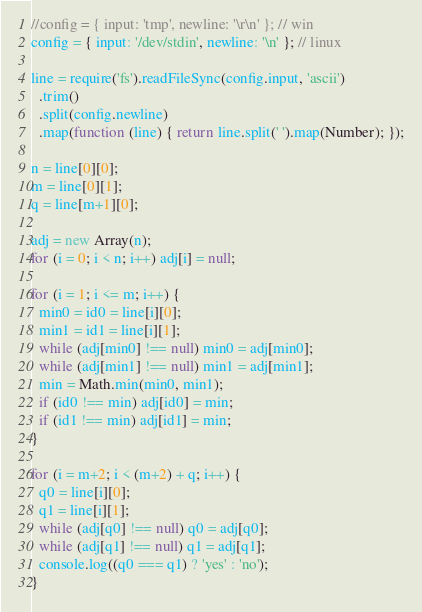<code> <loc_0><loc_0><loc_500><loc_500><_JavaScript_>//config = { input: 'tmp', newline: '\r\n' }; // win
config = { input: '/dev/stdin', newline: '\n' }; // linux

line = require('fs').readFileSync(config.input, 'ascii')
  .trim()
  .split(config.newline)
  .map(function (line) { return line.split(' ').map(Number); });

n = line[0][0];
m = line[0][1];
q = line[m+1][0];

adj = new Array(n);
for (i = 0; i < n; i++) adj[i] = null;

for (i = 1; i <= m; i++) {
  min0 = id0 = line[i][0];
  min1 = id1 = line[i][1];
  while (adj[min0] !== null) min0 = adj[min0];
  while (adj[min1] !== null) min1 = adj[min1];
  min = Math.min(min0, min1);
  if (id0 !== min) adj[id0] = min;
  if (id1 !== min) adj[id1] = min;
}

for (i = m+2; i < (m+2) + q; i++) {
  q0 = line[i][0];
  q1 = line[i][1];
  while (adj[q0] !== null) q0 = adj[q0];
  while (adj[q1] !== null) q1 = adj[q1];
  console.log((q0 === q1) ? 'yes' : 'no');
}</code> 